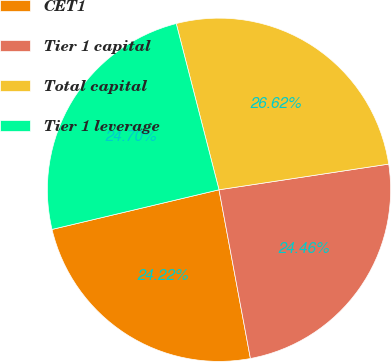Convert chart. <chart><loc_0><loc_0><loc_500><loc_500><pie_chart><fcel>CET1<fcel>Tier 1 capital<fcel>Total capital<fcel>Tier 1 leverage<nl><fcel>24.22%<fcel>24.46%<fcel>26.62%<fcel>24.7%<nl></chart> 